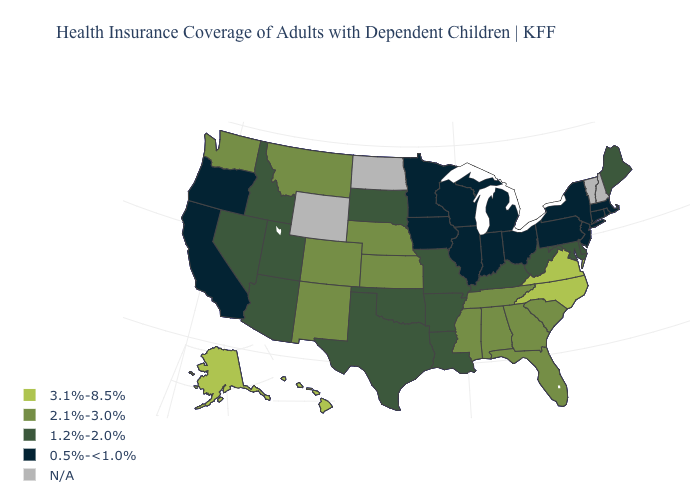Name the states that have a value in the range 0.5%-<1.0%?
Keep it brief. California, Connecticut, Illinois, Indiana, Iowa, Massachusetts, Michigan, Minnesota, New Jersey, New York, Ohio, Oregon, Pennsylvania, Rhode Island, Wisconsin. Name the states that have a value in the range 0.5%-<1.0%?
Keep it brief. California, Connecticut, Illinois, Indiana, Iowa, Massachusetts, Michigan, Minnesota, New Jersey, New York, Ohio, Oregon, Pennsylvania, Rhode Island, Wisconsin. Does Maine have the highest value in the Northeast?
Quick response, please. Yes. Does the map have missing data?
Keep it brief. Yes. Does Maryland have the highest value in the USA?
Be succinct. No. Does the map have missing data?
Be succinct. Yes. Name the states that have a value in the range 1.2%-2.0%?
Give a very brief answer. Arizona, Arkansas, Delaware, Idaho, Kentucky, Louisiana, Maine, Maryland, Missouri, Nevada, Oklahoma, South Dakota, Texas, Utah, West Virginia. Name the states that have a value in the range 1.2%-2.0%?
Short answer required. Arizona, Arkansas, Delaware, Idaho, Kentucky, Louisiana, Maine, Maryland, Missouri, Nevada, Oklahoma, South Dakota, Texas, Utah, West Virginia. What is the highest value in the Northeast ?
Concise answer only. 1.2%-2.0%. What is the value of Washington?
Answer briefly. 2.1%-3.0%. Name the states that have a value in the range 0.5%-<1.0%?
Be succinct. California, Connecticut, Illinois, Indiana, Iowa, Massachusetts, Michigan, Minnesota, New Jersey, New York, Ohio, Oregon, Pennsylvania, Rhode Island, Wisconsin. Name the states that have a value in the range 2.1%-3.0%?
Short answer required. Alabama, Colorado, Florida, Georgia, Kansas, Mississippi, Montana, Nebraska, New Mexico, South Carolina, Tennessee, Washington. 